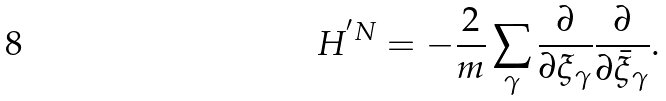Convert formula to latex. <formula><loc_0><loc_0><loc_500><loc_500>H ^ { ^ { \prime } N } = - \frac { 2 } { m } \sum _ { \gamma } \frac { \partial } { \partial \xi _ { \gamma } } \frac { \partial } { \partial \bar { \xi } _ { \gamma } } .</formula> 